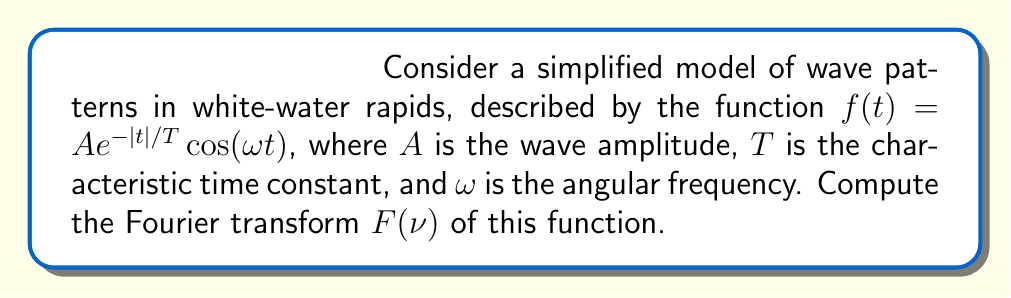Could you help me with this problem? To compute the Fourier transform, we'll follow these steps:

1) The Fourier transform is defined as:
   $$F(\nu) = \int_{-\infty}^{\infty} f(t)e^{-2\pi i\nu t}dt$$

2) Substituting our function:
   $$F(\nu) = \int_{-\infty}^{\infty} Ae^{-|t|/T}\cos(\omega t)e^{-2\pi i\nu t}dt$$

3) Using Euler's formula, $\cos(\omega t) = \frac{1}{2}(e^{i\omega t} + e^{-i\omega t})$:
   $$F(\nu) = \frac{A}{2}\int_{-\infty}^{\infty} e^{-|t|/T}(e^{i\omega t} + e^{-i\omega t})e^{-2\pi i\nu t}dt$$

4) Splitting the integral:
   $$F(\nu) = \frac{A}{2}\int_{-\infty}^{\infty} e^{-|t|/T}e^{i(\omega-2\pi\nu)t}dt + \frac{A}{2}\int_{-\infty}^{\infty} e^{-|t|/T}e^{-i(\omega+2\pi\nu)t}dt$$

5) Each integral can be evaluated separately. For the first integral:
   $$\int_{-\infty}^{\infty} e^{-|t|/T}e^{i(\omega-2\pi\nu)t}dt = \frac{2T}{1+(T(\omega-2\pi\nu))^2}$$

6) The second integral is similar with $\omega$ replaced by $-\omega$:
   $$\int_{-\infty}^{\infty} e^{-|t|/T}e^{-i(\omega+2\pi\nu)t}dt = \frac{2T}{1+(T(\omega+2\pi\nu))^2}$$

7) Combining the results:
   $$F(\nu) = AT\left(\frac{1}{1+(T(\omega-2\pi\nu))^2} + \frac{1}{1+(T(\omega+2\pi\nu))^2}\right)$$

8) This can be simplified to:
   $$F(\nu) = \frac{2AT}{1+(2\pi T\nu)^2-(\omega T)^2}$$
Answer: $$F(\nu) = \frac{2AT}{1+(2\pi T\nu)^2-(\omega T)^2}$$ 